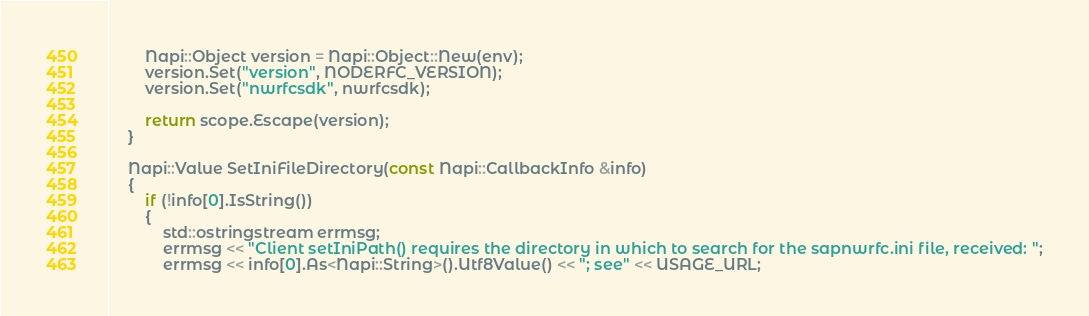<code> <loc_0><loc_0><loc_500><loc_500><_C++_>        Napi::Object version = Napi::Object::New(env);
        version.Set("version", NODERFC_VERSION);
        version.Set("nwrfcsdk", nwrfcsdk);

        return scope.Escape(version);
    }

    Napi::Value SetIniFileDirectory(const Napi::CallbackInfo &info)
    {
        if (!info[0].IsString())
        {
            std::ostringstream errmsg;
            errmsg << "Client setIniPath() requires the directory in which to search for the sapnwrfc.ini file, received: ";
            errmsg << info[0].As<Napi::String>().Utf8Value() << "; see" << USAGE_URL;</code> 